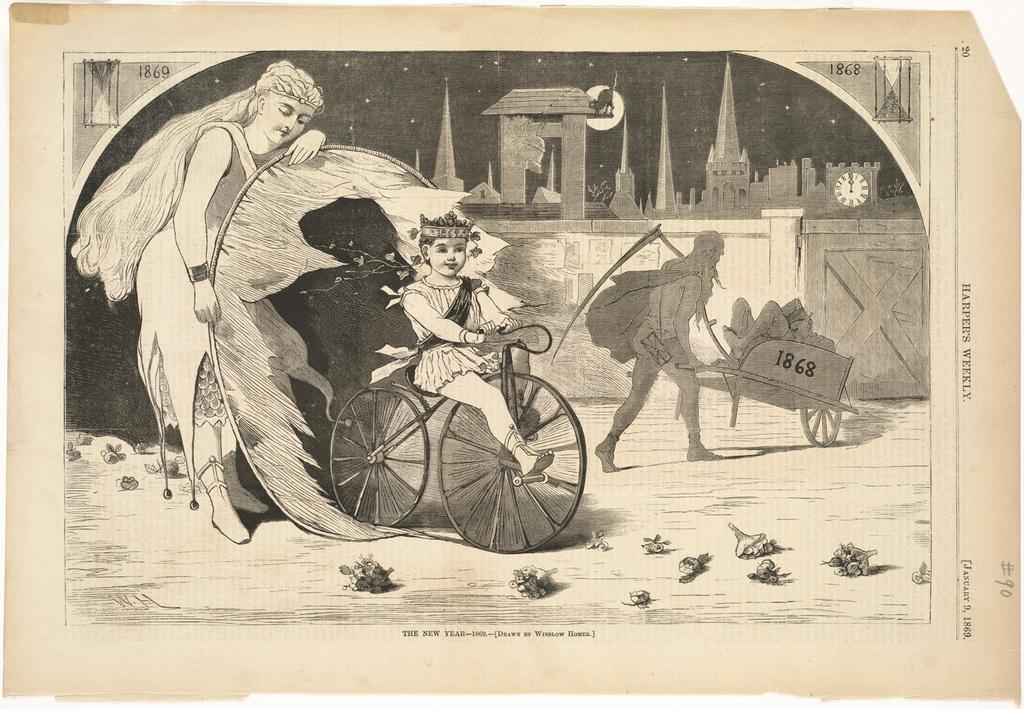What is the primary subject of the paper in the image? The paper contains numbers, words, an image of people, buildings, a clock, and other objects. Can you describe the content of the paper in more detail? The paper contains numbers, words, an image of people, buildings, and a clock. What other objects are present on the paper? There are other objects on the paper, but their specific nature is not mentioned in the facts. How does the air flow around the achiever in the image? There is no air or achiever present in the image; it features a paper with various content. What type of balance is depicted in the image? There is no balance depicted in the image; it features a paper with various content. 